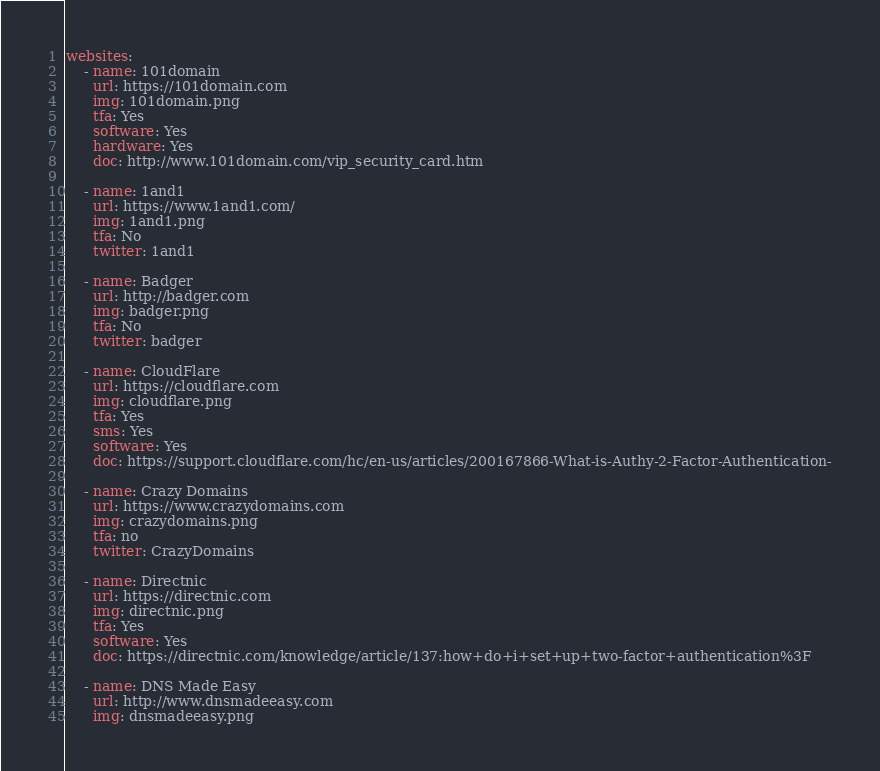<code> <loc_0><loc_0><loc_500><loc_500><_YAML_>websites:
    - name: 101domain
      url: https://101domain.com
      img: 101domain.png
      tfa: Yes
      software: Yes
      hardware: Yes
      doc: http://www.101domain.com/vip_security_card.htm

    - name: 1and1
      url: https://www.1and1.com/
      img: 1and1.png
      tfa: No
      twitter: 1and1

    - name: Badger
      url: http://badger.com
      img: badger.png
      tfa: No
      twitter: badger

    - name: CloudFlare
      url: https://cloudflare.com
      img: cloudflare.png
      tfa: Yes
      sms: Yes
      software: Yes
      doc: https://support.cloudflare.com/hc/en-us/articles/200167866-What-is-Authy-2-Factor-Authentication-

    - name: Crazy Domains
      url: https://www.crazydomains.com
      img: crazydomains.png
      tfa: no
      twitter: CrazyDomains

    - name: Directnic
      url: https://directnic.com
      img: directnic.png
      tfa: Yes
      software: Yes
      doc: https://directnic.com/knowledge/article/137:how+do+i+set+up+two-factor+authentication%3F

    - name: DNS Made Easy
      url: http://www.dnsmadeeasy.com
      img: dnsmadeeasy.png</code> 